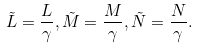Convert formula to latex. <formula><loc_0><loc_0><loc_500><loc_500>\tilde { L } = \frac { L } { \gamma } , \tilde { M } = \frac { M } { \gamma } , \tilde { N } = \frac { N } { \gamma } .</formula> 